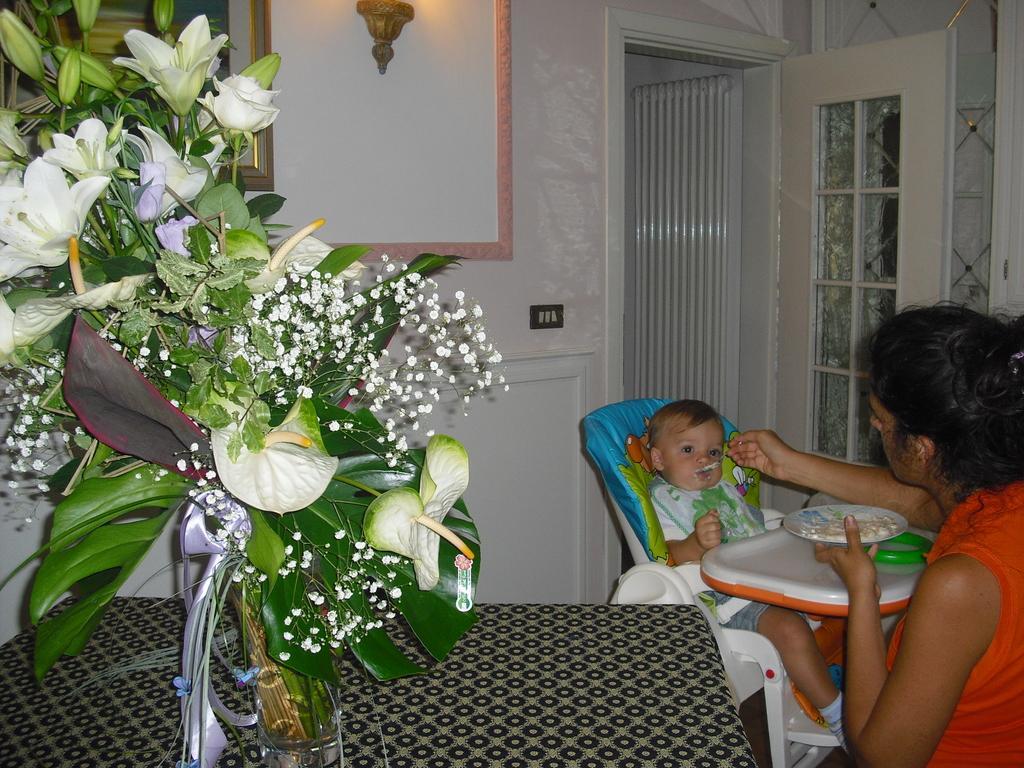In one or two sentences, can you explain what this image depicts? In this image there is a flower pot in the table , a baby sitting in the chair and eating the food , a man feeding the baby and at the back ground there is a frame fixed to the wall , a door and a switch board fixed to the wall. 